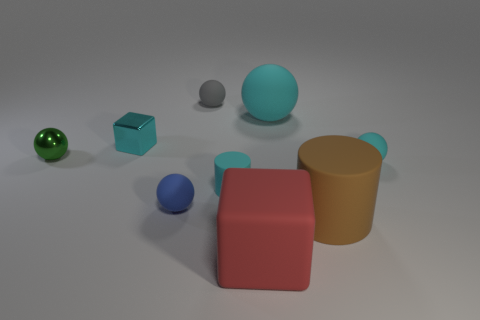Are there any purple balls that have the same size as the gray rubber thing?
Keep it short and to the point. No. There is a big thing that is both in front of the small cyan ball and behind the matte cube; what material is it?
Keep it short and to the point. Rubber. What number of metallic objects are small cyan blocks or green objects?
Offer a terse response. 2. What is the shape of the blue object that is made of the same material as the tiny gray object?
Ensure brevity in your answer.  Sphere. What number of tiny balls are in front of the small gray matte object and to the right of the green metallic ball?
Your answer should be compact. 2. Are there any other things that have the same shape as the tiny cyan shiny object?
Provide a succinct answer. Yes. There is a metal thing that is in front of the tiny cyan shiny thing; what size is it?
Ensure brevity in your answer.  Small. How many other objects are the same color as the metallic block?
Keep it short and to the point. 3. There is a tiny sphere that is on the right side of the small thing that is behind the tiny cyan block; what is it made of?
Ensure brevity in your answer.  Rubber. There is a small object that is in front of the tiny cyan matte cylinder; does it have the same color as the small metal block?
Provide a succinct answer. No. 